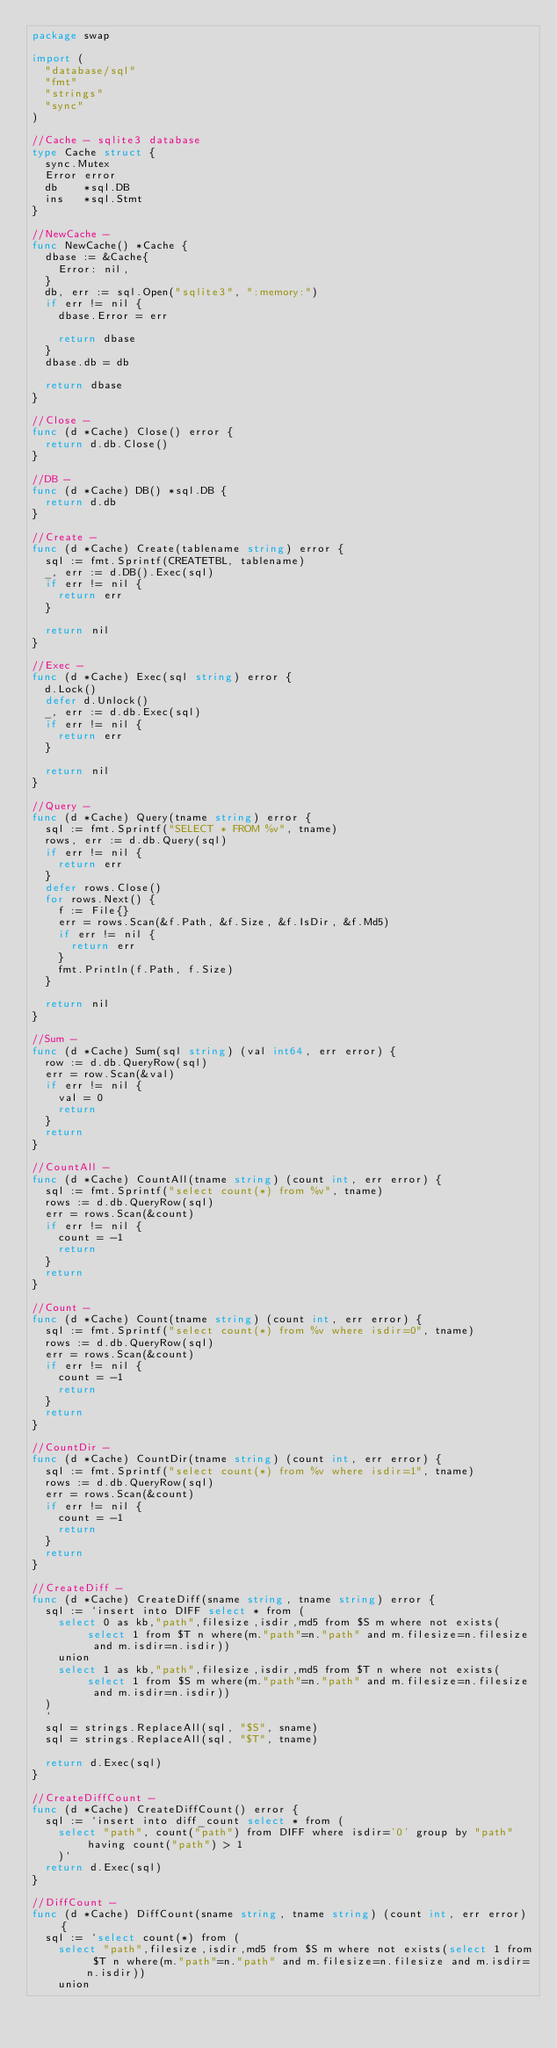<code> <loc_0><loc_0><loc_500><loc_500><_Go_>package swap

import (
	"database/sql"
	"fmt"
	"strings"
	"sync"
)

//Cache - sqlite3 database
type Cache struct {
	sync.Mutex
	Error error
	db    *sql.DB
	ins   *sql.Stmt
}

//NewCache -
func NewCache() *Cache {
	dbase := &Cache{
		Error: nil,
	}
	db, err := sql.Open("sqlite3", ":memory:")
	if err != nil {
		dbase.Error = err

		return dbase
	}
	dbase.db = db

	return dbase
}

//Close -
func (d *Cache) Close() error {
	return d.db.Close()
}

//DB -
func (d *Cache) DB() *sql.DB {
	return d.db
}

//Create -
func (d *Cache) Create(tablename string) error {
	sql := fmt.Sprintf(CREATETBL, tablename)
	_, err := d.DB().Exec(sql)
	if err != nil {
		return err
	}

	return nil
}

//Exec -
func (d *Cache) Exec(sql string) error {
	d.Lock()
	defer d.Unlock()
	_, err := d.db.Exec(sql)
	if err != nil {
		return err
	}

	return nil
}

//Query -
func (d *Cache) Query(tname string) error {
	sql := fmt.Sprintf("SELECT * FROM %v", tname)
	rows, err := d.db.Query(sql)
	if err != nil {
		return err
	}
	defer rows.Close()
	for rows.Next() {
		f := File{}
		err = rows.Scan(&f.Path, &f.Size, &f.IsDir, &f.Md5)
		if err != nil {
			return err
		}
		fmt.Println(f.Path, f.Size)
	}

	return nil
}

//Sum -
func (d *Cache) Sum(sql string) (val int64, err error) {
	row := d.db.QueryRow(sql)
	err = row.Scan(&val)
	if err != nil {
		val = 0
		return
	}
	return
}

//CountAll -
func (d *Cache) CountAll(tname string) (count int, err error) {
	sql := fmt.Sprintf("select count(*) from %v", tname)
	rows := d.db.QueryRow(sql)
	err = rows.Scan(&count)
	if err != nil {
		count = -1
		return
	}
	return
}

//Count -
func (d *Cache) Count(tname string) (count int, err error) {
	sql := fmt.Sprintf("select count(*) from %v where isdir=0", tname)
	rows := d.db.QueryRow(sql)
	err = rows.Scan(&count)
	if err != nil {
		count = -1
		return
	}
	return
}

//CountDir -
func (d *Cache) CountDir(tname string) (count int, err error) {
	sql := fmt.Sprintf("select count(*) from %v where isdir=1", tname)
	rows := d.db.QueryRow(sql)
	err = rows.Scan(&count)
	if err != nil {
		count = -1
		return
	}
	return
}

//CreateDiff -
func (d *Cache) CreateDiff(sname string, tname string) error {
	sql := `insert into DIFF select * from (
		select 0 as kb,"path",filesize,isdir,md5 from $S m where not exists(select 1 from $T n where(m."path"=n."path" and m.filesize=n.filesize and m.isdir=n.isdir))
		union
		select 1 as kb,"path",filesize,isdir,md5 from $T n where not exists(select 1 from $S m where(m."path"=n."path" and m.filesize=n.filesize and m.isdir=n.isdir))
	)
	`
	sql = strings.ReplaceAll(sql, "$S", sname)
	sql = strings.ReplaceAll(sql, "$T", tname)

	return d.Exec(sql)
}

//CreateDiffCount -
func (d *Cache) CreateDiffCount() error {
	sql := `insert into diff_count select * from (
		select "path", count("path") from DIFF where isdir='0' group by "path" having count("path") > 1
		)`
	return d.Exec(sql)
}

//DiffCount -
func (d *Cache) DiffCount(sname string, tname string) (count int, err error) {
	sql := `select count(*) from (
		select "path",filesize,isdir,md5 from $S m where not exists(select 1 from $T n where(m."path"=n."path" and m.filesize=n.filesize and m.isdir=n.isdir))
		union</code> 